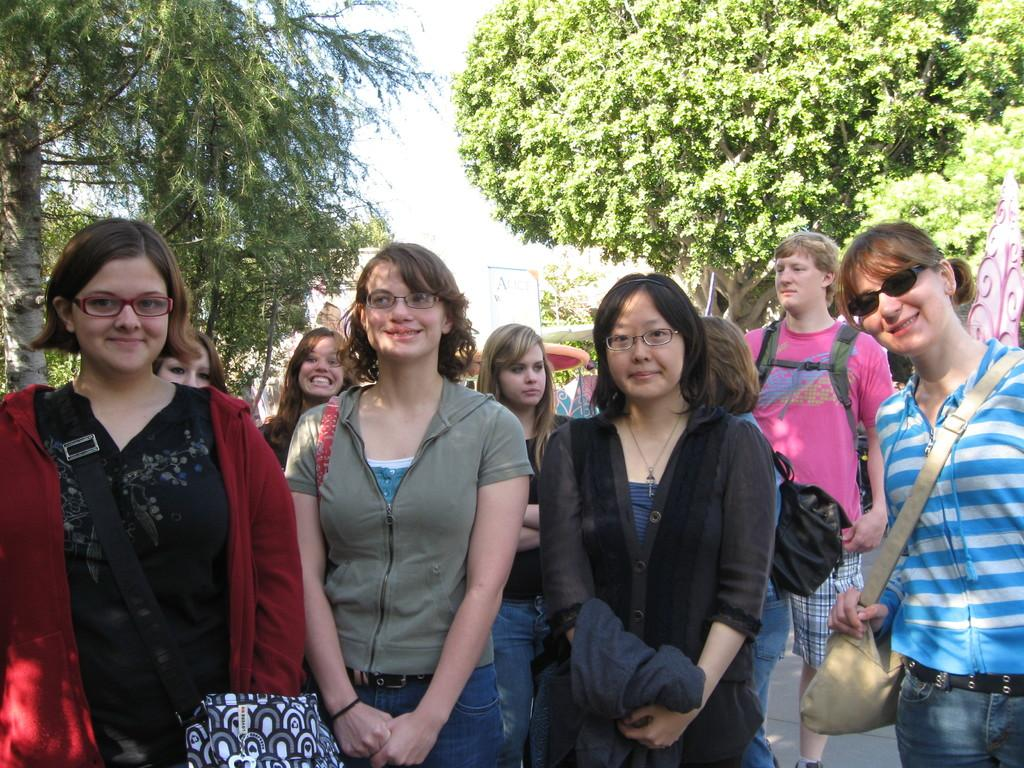What can be observed about the people in the image? There are people standing in the image, including a man and a woman. What is a common characteristic among most of the people in the image? Most of the people in the image are wearing spectacles. What can be seen in the background of the image? There are trees in the background of the image. How many fingers does the woman have on her left hand in the image? There is no information about the number of fingers on the woman's left hand in the image. 